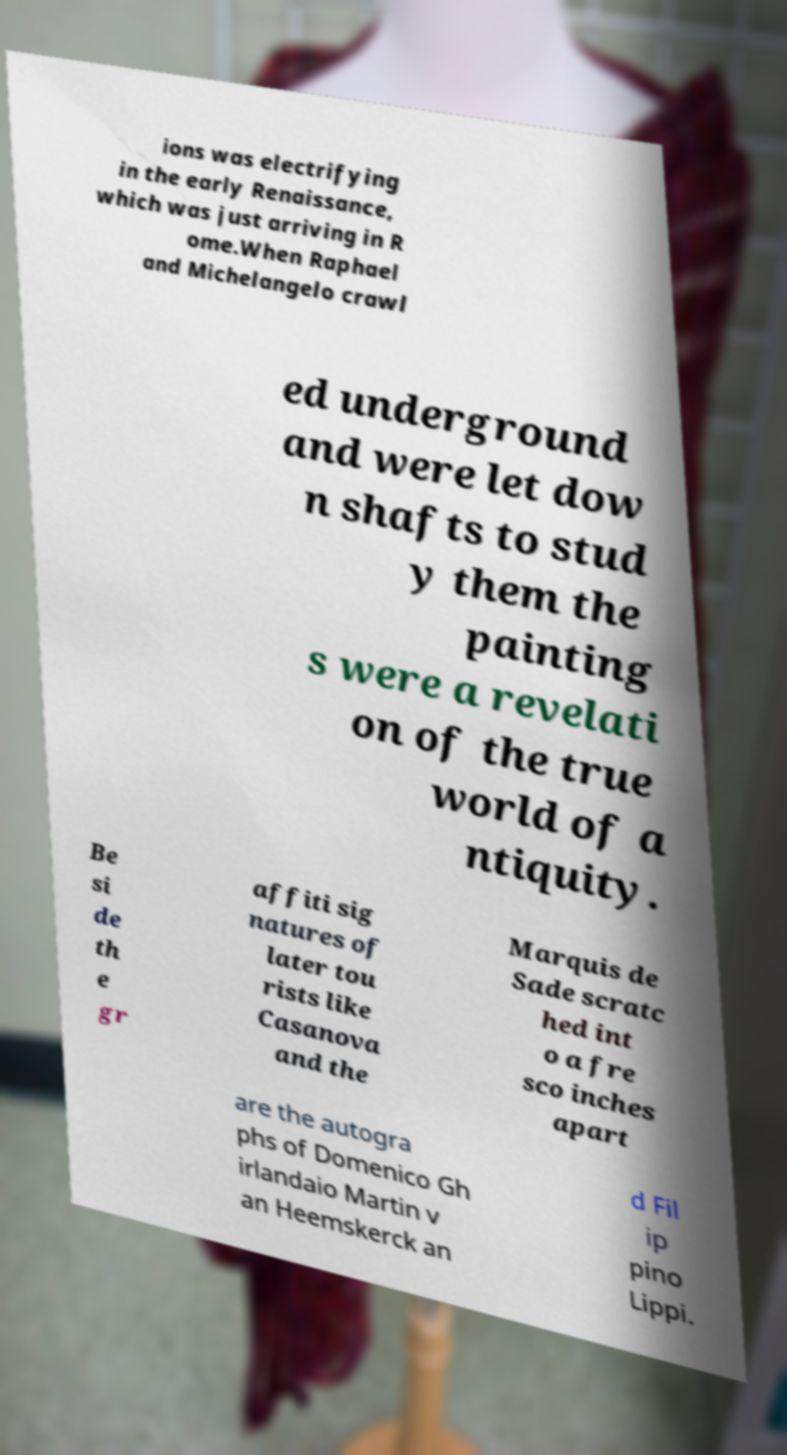Could you extract and type out the text from this image? ions was electrifying in the early Renaissance, which was just arriving in R ome.When Raphael and Michelangelo crawl ed underground and were let dow n shafts to stud y them the painting s were a revelati on of the true world of a ntiquity. Be si de th e gr affiti sig natures of later tou rists like Casanova and the Marquis de Sade scratc hed int o a fre sco inches apart are the autogra phs of Domenico Gh irlandaio Martin v an Heemskerck an d Fil ip pino Lippi. 